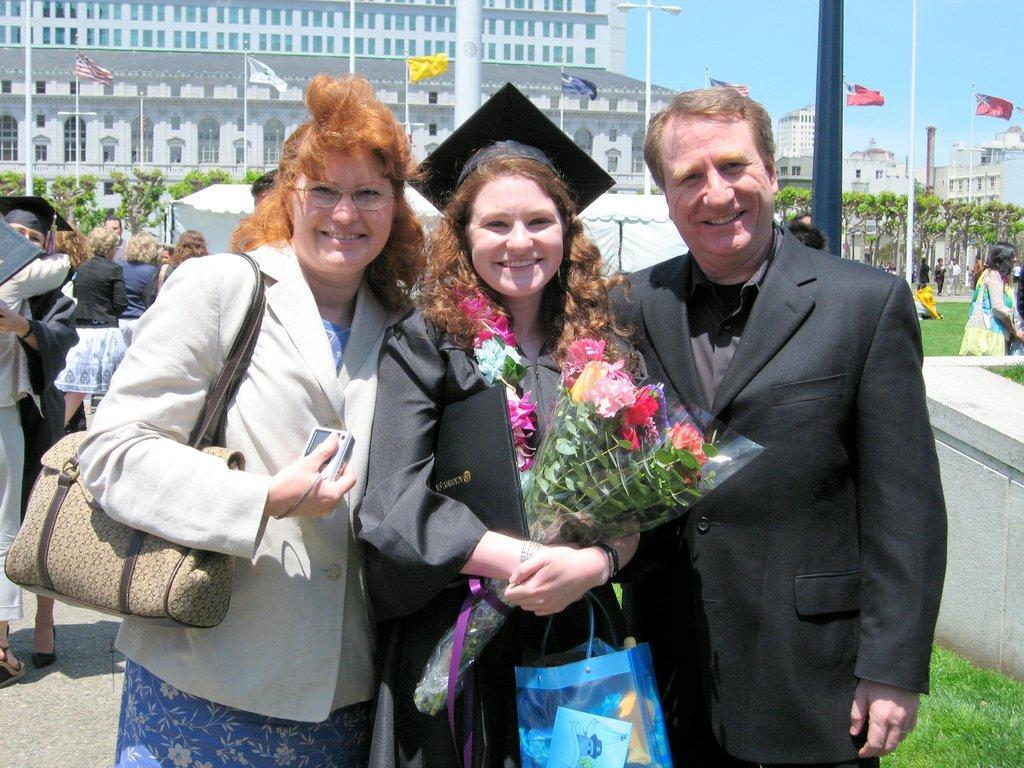Can you describe this image briefly? Here we can a see a three people who are standing and they are smiling. In the background there is a building, flags and trees. 